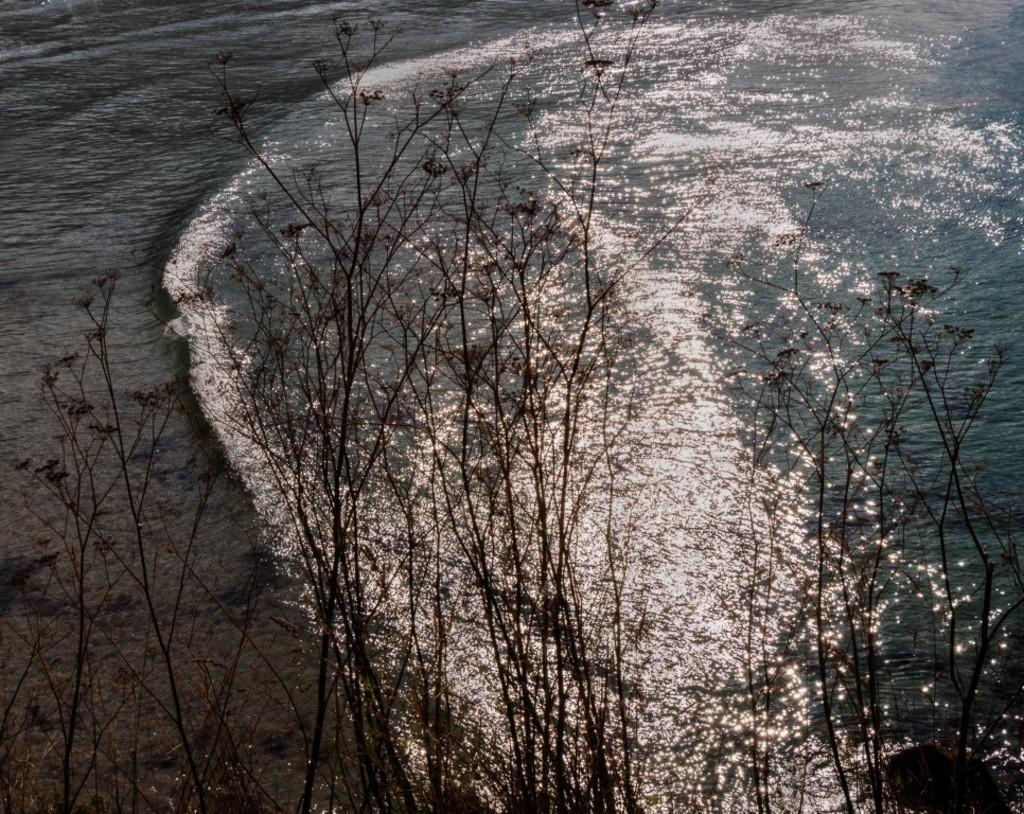What type of vegetation can be seen in the image? There are trees in the image. What natural element is visible in the image? There is water visible in the image. What type of holiday is being celebrated in the image? There is no indication of a holiday being celebrated in the image. Can you describe the facial expression of the trees in the image? Trees do not have facial expressions, so it is not possible to describe their expression. 